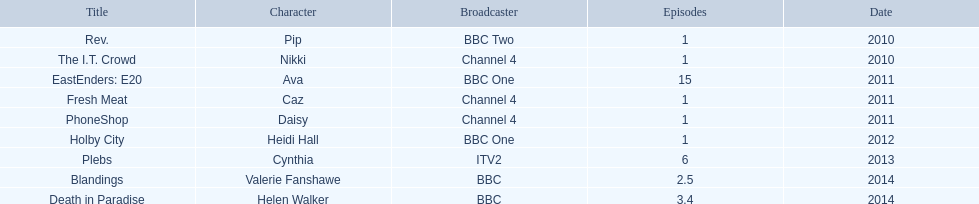What is the sole character she portrayed with broadcaster itv2? Cynthia. 